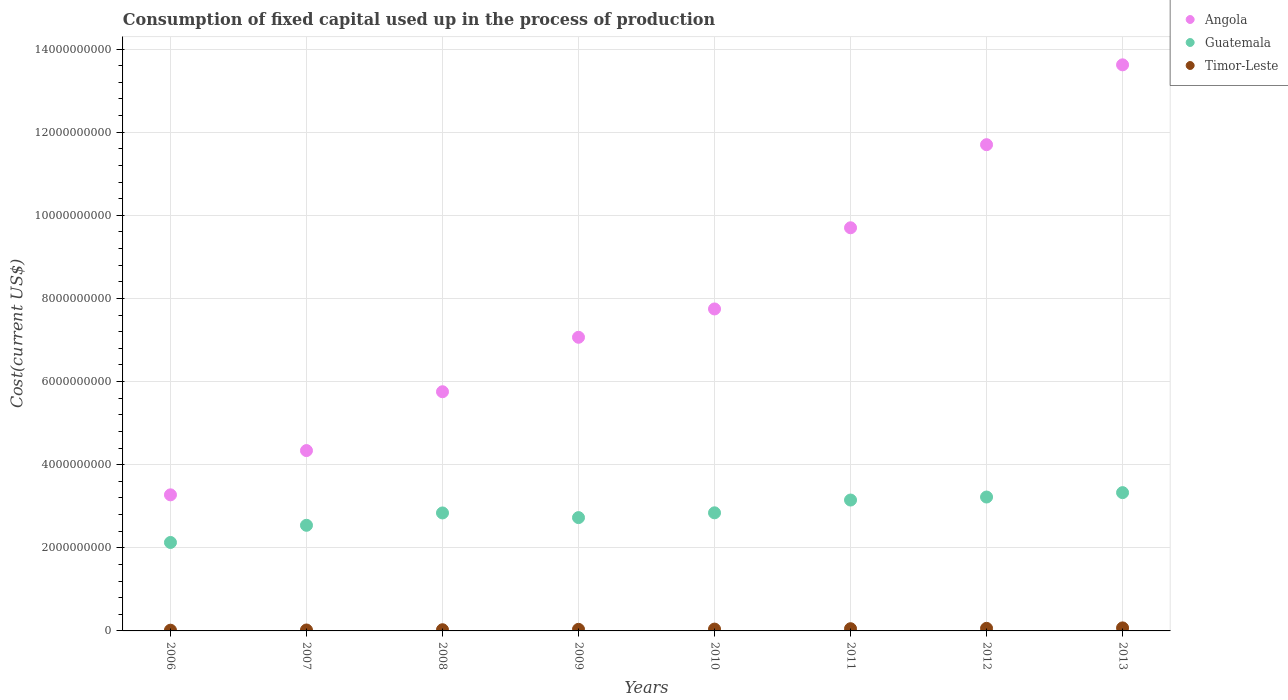How many different coloured dotlines are there?
Provide a short and direct response. 3. What is the amount consumed in the process of production in Guatemala in 2010?
Your response must be concise. 2.84e+09. Across all years, what is the maximum amount consumed in the process of production in Angola?
Give a very brief answer. 1.36e+1. Across all years, what is the minimum amount consumed in the process of production in Timor-Leste?
Ensure brevity in your answer.  1.75e+07. In which year was the amount consumed in the process of production in Timor-Leste maximum?
Your answer should be very brief. 2013. What is the total amount consumed in the process of production in Guatemala in the graph?
Ensure brevity in your answer.  2.28e+1. What is the difference between the amount consumed in the process of production in Angola in 2007 and that in 2010?
Provide a short and direct response. -3.41e+09. What is the difference between the amount consumed in the process of production in Timor-Leste in 2006 and the amount consumed in the process of production in Guatemala in 2012?
Your answer should be very brief. -3.20e+09. What is the average amount consumed in the process of production in Guatemala per year?
Offer a very short reply. 2.85e+09. In the year 2010, what is the difference between the amount consumed in the process of production in Guatemala and amount consumed in the process of production in Angola?
Offer a terse response. -4.91e+09. What is the ratio of the amount consumed in the process of production in Guatemala in 2010 to that in 2011?
Provide a succinct answer. 0.9. What is the difference between the highest and the second highest amount consumed in the process of production in Timor-Leste?
Provide a succinct answer. 1.07e+07. What is the difference between the highest and the lowest amount consumed in the process of production in Angola?
Give a very brief answer. 1.03e+1. In how many years, is the amount consumed in the process of production in Angola greater than the average amount consumed in the process of production in Angola taken over all years?
Make the answer very short. 3. Is it the case that in every year, the sum of the amount consumed in the process of production in Timor-Leste and amount consumed in the process of production in Guatemala  is greater than the amount consumed in the process of production in Angola?
Give a very brief answer. No. Is the amount consumed in the process of production in Timor-Leste strictly greater than the amount consumed in the process of production in Angola over the years?
Your answer should be very brief. No. How many dotlines are there?
Provide a succinct answer. 3. Are the values on the major ticks of Y-axis written in scientific E-notation?
Give a very brief answer. No. Does the graph contain any zero values?
Give a very brief answer. No. Does the graph contain grids?
Ensure brevity in your answer.  Yes. How many legend labels are there?
Your response must be concise. 3. How are the legend labels stacked?
Ensure brevity in your answer.  Vertical. What is the title of the graph?
Provide a succinct answer. Consumption of fixed capital used up in the process of production. Does "Czech Republic" appear as one of the legend labels in the graph?
Ensure brevity in your answer.  No. What is the label or title of the X-axis?
Your answer should be very brief. Years. What is the label or title of the Y-axis?
Make the answer very short. Cost(current US$). What is the Cost(current US$) in Angola in 2006?
Offer a very short reply. 3.27e+09. What is the Cost(current US$) in Guatemala in 2006?
Ensure brevity in your answer.  2.13e+09. What is the Cost(current US$) of Timor-Leste in 2006?
Make the answer very short. 1.75e+07. What is the Cost(current US$) of Angola in 2007?
Give a very brief answer. 4.34e+09. What is the Cost(current US$) of Guatemala in 2007?
Your response must be concise. 2.54e+09. What is the Cost(current US$) in Timor-Leste in 2007?
Provide a succinct answer. 2.24e+07. What is the Cost(current US$) of Angola in 2008?
Offer a terse response. 5.75e+09. What is the Cost(current US$) in Guatemala in 2008?
Ensure brevity in your answer.  2.84e+09. What is the Cost(current US$) in Timor-Leste in 2008?
Provide a short and direct response. 2.86e+07. What is the Cost(current US$) in Angola in 2009?
Keep it short and to the point. 7.07e+09. What is the Cost(current US$) in Guatemala in 2009?
Your response must be concise. 2.73e+09. What is the Cost(current US$) in Timor-Leste in 2009?
Offer a terse response. 3.83e+07. What is the Cost(current US$) of Angola in 2010?
Ensure brevity in your answer.  7.75e+09. What is the Cost(current US$) of Guatemala in 2010?
Your answer should be very brief. 2.84e+09. What is the Cost(current US$) of Timor-Leste in 2010?
Offer a very short reply. 4.41e+07. What is the Cost(current US$) in Angola in 2011?
Your answer should be compact. 9.70e+09. What is the Cost(current US$) of Guatemala in 2011?
Keep it short and to the point. 3.15e+09. What is the Cost(current US$) of Timor-Leste in 2011?
Offer a terse response. 5.32e+07. What is the Cost(current US$) in Angola in 2012?
Provide a short and direct response. 1.17e+1. What is the Cost(current US$) in Guatemala in 2012?
Provide a succinct answer. 3.22e+09. What is the Cost(current US$) of Timor-Leste in 2012?
Offer a very short reply. 6.21e+07. What is the Cost(current US$) in Angola in 2013?
Ensure brevity in your answer.  1.36e+1. What is the Cost(current US$) in Guatemala in 2013?
Keep it short and to the point. 3.33e+09. What is the Cost(current US$) in Timor-Leste in 2013?
Your answer should be compact. 7.29e+07. Across all years, what is the maximum Cost(current US$) of Angola?
Make the answer very short. 1.36e+1. Across all years, what is the maximum Cost(current US$) of Guatemala?
Provide a short and direct response. 3.33e+09. Across all years, what is the maximum Cost(current US$) in Timor-Leste?
Offer a terse response. 7.29e+07. Across all years, what is the minimum Cost(current US$) of Angola?
Offer a very short reply. 3.27e+09. Across all years, what is the minimum Cost(current US$) in Guatemala?
Your response must be concise. 2.13e+09. Across all years, what is the minimum Cost(current US$) of Timor-Leste?
Your response must be concise. 1.75e+07. What is the total Cost(current US$) of Angola in the graph?
Provide a short and direct response. 6.32e+1. What is the total Cost(current US$) of Guatemala in the graph?
Provide a succinct answer. 2.28e+1. What is the total Cost(current US$) of Timor-Leste in the graph?
Your answer should be compact. 3.39e+08. What is the difference between the Cost(current US$) of Angola in 2006 and that in 2007?
Your answer should be very brief. -1.07e+09. What is the difference between the Cost(current US$) in Guatemala in 2006 and that in 2007?
Your answer should be compact. -4.13e+08. What is the difference between the Cost(current US$) of Timor-Leste in 2006 and that in 2007?
Keep it short and to the point. -4.92e+06. What is the difference between the Cost(current US$) of Angola in 2006 and that in 2008?
Your answer should be very brief. -2.48e+09. What is the difference between the Cost(current US$) of Guatemala in 2006 and that in 2008?
Your answer should be compact. -7.11e+08. What is the difference between the Cost(current US$) of Timor-Leste in 2006 and that in 2008?
Give a very brief answer. -1.11e+07. What is the difference between the Cost(current US$) of Angola in 2006 and that in 2009?
Your answer should be compact. -3.79e+09. What is the difference between the Cost(current US$) in Guatemala in 2006 and that in 2009?
Your answer should be compact. -5.98e+08. What is the difference between the Cost(current US$) of Timor-Leste in 2006 and that in 2009?
Provide a succinct answer. -2.08e+07. What is the difference between the Cost(current US$) in Angola in 2006 and that in 2010?
Provide a succinct answer. -4.47e+09. What is the difference between the Cost(current US$) of Guatemala in 2006 and that in 2010?
Give a very brief answer. -7.13e+08. What is the difference between the Cost(current US$) in Timor-Leste in 2006 and that in 2010?
Your answer should be compact. -2.67e+07. What is the difference between the Cost(current US$) in Angola in 2006 and that in 2011?
Your response must be concise. -6.43e+09. What is the difference between the Cost(current US$) of Guatemala in 2006 and that in 2011?
Your answer should be compact. -1.02e+09. What is the difference between the Cost(current US$) in Timor-Leste in 2006 and that in 2011?
Ensure brevity in your answer.  -3.57e+07. What is the difference between the Cost(current US$) in Angola in 2006 and that in 2012?
Provide a succinct answer. -8.42e+09. What is the difference between the Cost(current US$) of Guatemala in 2006 and that in 2012?
Provide a short and direct response. -1.09e+09. What is the difference between the Cost(current US$) in Timor-Leste in 2006 and that in 2012?
Your answer should be very brief. -4.46e+07. What is the difference between the Cost(current US$) in Angola in 2006 and that in 2013?
Your answer should be compact. -1.03e+1. What is the difference between the Cost(current US$) of Guatemala in 2006 and that in 2013?
Offer a very short reply. -1.20e+09. What is the difference between the Cost(current US$) in Timor-Leste in 2006 and that in 2013?
Make the answer very short. -5.54e+07. What is the difference between the Cost(current US$) in Angola in 2007 and that in 2008?
Offer a very short reply. -1.42e+09. What is the difference between the Cost(current US$) in Guatemala in 2007 and that in 2008?
Your answer should be compact. -2.97e+08. What is the difference between the Cost(current US$) of Timor-Leste in 2007 and that in 2008?
Provide a short and direct response. -6.15e+06. What is the difference between the Cost(current US$) of Angola in 2007 and that in 2009?
Offer a terse response. -2.73e+09. What is the difference between the Cost(current US$) of Guatemala in 2007 and that in 2009?
Keep it short and to the point. -1.85e+08. What is the difference between the Cost(current US$) in Timor-Leste in 2007 and that in 2009?
Provide a short and direct response. -1.58e+07. What is the difference between the Cost(current US$) in Angola in 2007 and that in 2010?
Provide a succinct answer. -3.41e+09. What is the difference between the Cost(current US$) of Guatemala in 2007 and that in 2010?
Your answer should be compact. -3.00e+08. What is the difference between the Cost(current US$) in Timor-Leste in 2007 and that in 2010?
Provide a short and direct response. -2.17e+07. What is the difference between the Cost(current US$) in Angola in 2007 and that in 2011?
Offer a very short reply. -5.36e+09. What is the difference between the Cost(current US$) in Guatemala in 2007 and that in 2011?
Offer a very short reply. -6.08e+08. What is the difference between the Cost(current US$) in Timor-Leste in 2007 and that in 2011?
Keep it short and to the point. -3.08e+07. What is the difference between the Cost(current US$) of Angola in 2007 and that in 2012?
Provide a short and direct response. -7.36e+09. What is the difference between the Cost(current US$) in Guatemala in 2007 and that in 2012?
Provide a short and direct response. -6.80e+08. What is the difference between the Cost(current US$) of Timor-Leste in 2007 and that in 2012?
Your response must be concise. -3.97e+07. What is the difference between the Cost(current US$) in Angola in 2007 and that in 2013?
Your response must be concise. -9.28e+09. What is the difference between the Cost(current US$) in Guatemala in 2007 and that in 2013?
Your response must be concise. -7.86e+08. What is the difference between the Cost(current US$) in Timor-Leste in 2007 and that in 2013?
Offer a very short reply. -5.04e+07. What is the difference between the Cost(current US$) of Angola in 2008 and that in 2009?
Provide a short and direct response. -1.31e+09. What is the difference between the Cost(current US$) of Guatemala in 2008 and that in 2009?
Keep it short and to the point. 1.12e+08. What is the difference between the Cost(current US$) in Timor-Leste in 2008 and that in 2009?
Give a very brief answer. -9.69e+06. What is the difference between the Cost(current US$) in Angola in 2008 and that in 2010?
Your answer should be compact. -1.99e+09. What is the difference between the Cost(current US$) in Guatemala in 2008 and that in 2010?
Provide a short and direct response. -2.84e+06. What is the difference between the Cost(current US$) of Timor-Leste in 2008 and that in 2010?
Keep it short and to the point. -1.56e+07. What is the difference between the Cost(current US$) in Angola in 2008 and that in 2011?
Your answer should be very brief. -3.94e+09. What is the difference between the Cost(current US$) in Guatemala in 2008 and that in 2011?
Your answer should be very brief. -3.11e+08. What is the difference between the Cost(current US$) in Timor-Leste in 2008 and that in 2011?
Offer a terse response. -2.46e+07. What is the difference between the Cost(current US$) of Angola in 2008 and that in 2012?
Keep it short and to the point. -5.94e+09. What is the difference between the Cost(current US$) of Guatemala in 2008 and that in 2012?
Provide a short and direct response. -3.83e+08. What is the difference between the Cost(current US$) of Timor-Leste in 2008 and that in 2012?
Give a very brief answer. -3.36e+07. What is the difference between the Cost(current US$) in Angola in 2008 and that in 2013?
Offer a very short reply. -7.87e+09. What is the difference between the Cost(current US$) in Guatemala in 2008 and that in 2013?
Offer a terse response. -4.88e+08. What is the difference between the Cost(current US$) in Timor-Leste in 2008 and that in 2013?
Offer a terse response. -4.43e+07. What is the difference between the Cost(current US$) in Angola in 2009 and that in 2010?
Offer a very short reply. -6.82e+08. What is the difference between the Cost(current US$) of Guatemala in 2009 and that in 2010?
Your response must be concise. -1.15e+08. What is the difference between the Cost(current US$) in Timor-Leste in 2009 and that in 2010?
Provide a short and direct response. -5.89e+06. What is the difference between the Cost(current US$) in Angola in 2009 and that in 2011?
Ensure brevity in your answer.  -2.63e+09. What is the difference between the Cost(current US$) in Guatemala in 2009 and that in 2011?
Your response must be concise. -4.23e+08. What is the difference between the Cost(current US$) in Timor-Leste in 2009 and that in 2011?
Offer a terse response. -1.49e+07. What is the difference between the Cost(current US$) of Angola in 2009 and that in 2012?
Provide a short and direct response. -4.63e+09. What is the difference between the Cost(current US$) in Guatemala in 2009 and that in 2012?
Make the answer very short. -4.95e+08. What is the difference between the Cost(current US$) of Timor-Leste in 2009 and that in 2012?
Your response must be concise. -2.39e+07. What is the difference between the Cost(current US$) of Angola in 2009 and that in 2013?
Provide a succinct answer. -6.55e+09. What is the difference between the Cost(current US$) of Guatemala in 2009 and that in 2013?
Offer a terse response. -6.01e+08. What is the difference between the Cost(current US$) of Timor-Leste in 2009 and that in 2013?
Keep it short and to the point. -3.46e+07. What is the difference between the Cost(current US$) in Angola in 2010 and that in 2011?
Ensure brevity in your answer.  -1.95e+09. What is the difference between the Cost(current US$) of Guatemala in 2010 and that in 2011?
Keep it short and to the point. -3.08e+08. What is the difference between the Cost(current US$) in Timor-Leste in 2010 and that in 2011?
Offer a very short reply. -9.04e+06. What is the difference between the Cost(current US$) in Angola in 2010 and that in 2012?
Give a very brief answer. -3.95e+09. What is the difference between the Cost(current US$) in Guatemala in 2010 and that in 2012?
Keep it short and to the point. -3.80e+08. What is the difference between the Cost(current US$) of Timor-Leste in 2010 and that in 2012?
Give a very brief answer. -1.80e+07. What is the difference between the Cost(current US$) in Angola in 2010 and that in 2013?
Offer a terse response. -5.87e+09. What is the difference between the Cost(current US$) in Guatemala in 2010 and that in 2013?
Your answer should be very brief. -4.86e+08. What is the difference between the Cost(current US$) in Timor-Leste in 2010 and that in 2013?
Keep it short and to the point. -2.87e+07. What is the difference between the Cost(current US$) in Angola in 2011 and that in 2012?
Your response must be concise. -2.00e+09. What is the difference between the Cost(current US$) of Guatemala in 2011 and that in 2012?
Your response must be concise. -7.23e+07. What is the difference between the Cost(current US$) of Timor-Leste in 2011 and that in 2012?
Offer a very short reply. -8.93e+06. What is the difference between the Cost(current US$) in Angola in 2011 and that in 2013?
Your answer should be compact. -3.92e+09. What is the difference between the Cost(current US$) of Guatemala in 2011 and that in 2013?
Your response must be concise. -1.78e+08. What is the difference between the Cost(current US$) of Timor-Leste in 2011 and that in 2013?
Ensure brevity in your answer.  -1.97e+07. What is the difference between the Cost(current US$) in Angola in 2012 and that in 2013?
Provide a succinct answer. -1.92e+09. What is the difference between the Cost(current US$) of Guatemala in 2012 and that in 2013?
Provide a succinct answer. -1.06e+08. What is the difference between the Cost(current US$) in Timor-Leste in 2012 and that in 2013?
Your response must be concise. -1.07e+07. What is the difference between the Cost(current US$) of Angola in 2006 and the Cost(current US$) of Guatemala in 2007?
Your answer should be compact. 7.33e+08. What is the difference between the Cost(current US$) of Angola in 2006 and the Cost(current US$) of Timor-Leste in 2007?
Your response must be concise. 3.25e+09. What is the difference between the Cost(current US$) in Guatemala in 2006 and the Cost(current US$) in Timor-Leste in 2007?
Provide a succinct answer. 2.11e+09. What is the difference between the Cost(current US$) in Angola in 2006 and the Cost(current US$) in Guatemala in 2008?
Ensure brevity in your answer.  4.35e+08. What is the difference between the Cost(current US$) in Angola in 2006 and the Cost(current US$) in Timor-Leste in 2008?
Provide a succinct answer. 3.25e+09. What is the difference between the Cost(current US$) of Guatemala in 2006 and the Cost(current US$) of Timor-Leste in 2008?
Your answer should be compact. 2.10e+09. What is the difference between the Cost(current US$) of Angola in 2006 and the Cost(current US$) of Guatemala in 2009?
Ensure brevity in your answer.  5.48e+08. What is the difference between the Cost(current US$) in Angola in 2006 and the Cost(current US$) in Timor-Leste in 2009?
Provide a succinct answer. 3.24e+09. What is the difference between the Cost(current US$) in Guatemala in 2006 and the Cost(current US$) in Timor-Leste in 2009?
Offer a very short reply. 2.09e+09. What is the difference between the Cost(current US$) in Angola in 2006 and the Cost(current US$) in Guatemala in 2010?
Give a very brief answer. 4.33e+08. What is the difference between the Cost(current US$) of Angola in 2006 and the Cost(current US$) of Timor-Leste in 2010?
Your answer should be compact. 3.23e+09. What is the difference between the Cost(current US$) in Guatemala in 2006 and the Cost(current US$) in Timor-Leste in 2010?
Your answer should be very brief. 2.08e+09. What is the difference between the Cost(current US$) in Angola in 2006 and the Cost(current US$) in Guatemala in 2011?
Provide a short and direct response. 1.25e+08. What is the difference between the Cost(current US$) of Angola in 2006 and the Cost(current US$) of Timor-Leste in 2011?
Provide a short and direct response. 3.22e+09. What is the difference between the Cost(current US$) of Guatemala in 2006 and the Cost(current US$) of Timor-Leste in 2011?
Provide a succinct answer. 2.07e+09. What is the difference between the Cost(current US$) of Angola in 2006 and the Cost(current US$) of Guatemala in 2012?
Offer a very short reply. 5.26e+07. What is the difference between the Cost(current US$) of Angola in 2006 and the Cost(current US$) of Timor-Leste in 2012?
Your answer should be compact. 3.21e+09. What is the difference between the Cost(current US$) in Guatemala in 2006 and the Cost(current US$) in Timor-Leste in 2012?
Give a very brief answer. 2.07e+09. What is the difference between the Cost(current US$) in Angola in 2006 and the Cost(current US$) in Guatemala in 2013?
Ensure brevity in your answer.  -5.30e+07. What is the difference between the Cost(current US$) of Angola in 2006 and the Cost(current US$) of Timor-Leste in 2013?
Keep it short and to the point. 3.20e+09. What is the difference between the Cost(current US$) of Guatemala in 2006 and the Cost(current US$) of Timor-Leste in 2013?
Your answer should be compact. 2.06e+09. What is the difference between the Cost(current US$) in Angola in 2007 and the Cost(current US$) in Guatemala in 2008?
Your response must be concise. 1.50e+09. What is the difference between the Cost(current US$) in Angola in 2007 and the Cost(current US$) in Timor-Leste in 2008?
Keep it short and to the point. 4.31e+09. What is the difference between the Cost(current US$) in Guatemala in 2007 and the Cost(current US$) in Timor-Leste in 2008?
Your response must be concise. 2.51e+09. What is the difference between the Cost(current US$) of Angola in 2007 and the Cost(current US$) of Guatemala in 2009?
Provide a succinct answer. 1.61e+09. What is the difference between the Cost(current US$) in Angola in 2007 and the Cost(current US$) in Timor-Leste in 2009?
Make the answer very short. 4.30e+09. What is the difference between the Cost(current US$) of Guatemala in 2007 and the Cost(current US$) of Timor-Leste in 2009?
Make the answer very short. 2.50e+09. What is the difference between the Cost(current US$) of Angola in 2007 and the Cost(current US$) of Guatemala in 2010?
Your answer should be very brief. 1.50e+09. What is the difference between the Cost(current US$) of Angola in 2007 and the Cost(current US$) of Timor-Leste in 2010?
Offer a very short reply. 4.30e+09. What is the difference between the Cost(current US$) in Guatemala in 2007 and the Cost(current US$) in Timor-Leste in 2010?
Your answer should be compact. 2.50e+09. What is the difference between the Cost(current US$) in Angola in 2007 and the Cost(current US$) in Guatemala in 2011?
Your response must be concise. 1.19e+09. What is the difference between the Cost(current US$) in Angola in 2007 and the Cost(current US$) in Timor-Leste in 2011?
Make the answer very short. 4.29e+09. What is the difference between the Cost(current US$) of Guatemala in 2007 and the Cost(current US$) of Timor-Leste in 2011?
Provide a succinct answer. 2.49e+09. What is the difference between the Cost(current US$) of Angola in 2007 and the Cost(current US$) of Guatemala in 2012?
Offer a very short reply. 1.12e+09. What is the difference between the Cost(current US$) in Angola in 2007 and the Cost(current US$) in Timor-Leste in 2012?
Your response must be concise. 4.28e+09. What is the difference between the Cost(current US$) in Guatemala in 2007 and the Cost(current US$) in Timor-Leste in 2012?
Your answer should be very brief. 2.48e+09. What is the difference between the Cost(current US$) in Angola in 2007 and the Cost(current US$) in Guatemala in 2013?
Provide a short and direct response. 1.01e+09. What is the difference between the Cost(current US$) of Angola in 2007 and the Cost(current US$) of Timor-Leste in 2013?
Offer a very short reply. 4.27e+09. What is the difference between the Cost(current US$) in Guatemala in 2007 and the Cost(current US$) in Timor-Leste in 2013?
Your response must be concise. 2.47e+09. What is the difference between the Cost(current US$) in Angola in 2008 and the Cost(current US$) in Guatemala in 2009?
Keep it short and to the point. 3.03e+09. What is the difference between the Cost(current US$) in Angola in 2008 and the Cost(current US$) in Timor-Leste in 2009?
Your answer should be compact. 5.72e+09. What is the difference between the Cost(current US$) in Guatemala in 2008 and the Cost(current US$) in Timor-Leste in 2009?
Offer a terse response. 2.80e+09. What is the difference between the Cost(current US$) of Angola in 2008 and the Cost(current US$) of Guatemala in 2010?
Offer a very short reply. 2.91e+09. What is the difference between the Cost(current US$) of Angola in 2008 and the Cost(current US$) of Timor-Leste in 2010?
Your answer should be very brief. 5.71e+09. What is the difference between the Cost(current US$) of Guatemala in 2008 and the Cost(current US$) of Timor-Leste in 2010?
Ensure brevity in your answer.  2.79e+09. What is the difference between the Cost(current US$) of Angola in 2008 and the Cost(current US$) of Guatemala in 2011?
Make the answer very short. 2.61e+09. What is the difference between the Cost(current US$) of Angola in 2008 and the Cost(current US$) of Timor-Leste in 2011?
Offer a terse response. 5.70e+09. What is the difference between the Cost(current US$) in Guatemala in 2008 and the Cost(current US$) in Timor-Leste in 2011?
Your answer should be very brief. 2.79e+09. What is the difference between the Cost(current US$) of Angola in 2008 and the Cost(current US$) of Guatemala in 2012?
Ensure brevity in your answer.  2.53e+09. What is the difference between the Cost(current US$) of Angola in 2008 and the Cost(current US$) of Timor-Leste in 2012?
Give a very brief answer. 5.69e+09. What is the difference between the Cost(current US$) of Guatemala in 2008 and the Cost(current US$) of Timor-Leste in 2012?
Your answer should be compact. 2.78e+09. What is the difference between the Cost(current US$) in Angola in 2008 and the Cost(current US$) in Guatemala in 2013?
Your response must be concise. 2.43e+09. What is the difference between the Cost(current US$) in Angola in 2008 and the Cost(current US$) in Timor-Leste in 2013?
Offer a terse response. 5.68e+09. What is the difference between the Cost(current US$) of Guatemala in 2008 and the Cost(current US$) of Timor-Leste in 2013?
Provide a succinct answer. 2.77e+09. What is the difference between the Cost(current US$) in Angola in 2009 and the Cost(current US$) in Guatemala in 2010?
Give a very brief answer. 4.22e+09. What is the difference between the Cost(current US$) in Angola in 2009 and the Cost(current US$) in Timor-Leste in 2010?
Your answer should be compact. 7.02e+09. What is the difference between the Cost(current US$) in Guatemala in 2009 and the Cost(current US$) in Timor-Leste in 2010?
Your answer should be compact. 2.68e+09. What is the difference between the Cost(current US$) of Angola in 2009 and the Cost(current US$) of Guatemala in 2011?
Provide a succinct answer. 3.92e+09. What is the difference between the Cost(current US$) in Angola in 2009 and the Cost(current US$) in Timor-Leste in 2011?
Provide a succinct answer. 7.01e+09. What is the difference between the Cost(current US$) of Guatemala in 2009 and the Cost(current US$) of Timor-Leste in 2011?
Keep it short and to the point. 2.67e+09. What is the difference between the Cost(current US$) in Angola in 2009 and the Cost(current US$) in Guatemala in 2012?
Your response must be concise. 3.84e+09. What is the difference between the Cost(current US$) of Angola in 2009 and the Cost(current US$) of Timor-Leste in 2012?
Your answer should be very brief. 7.00e+09. What is the difference between the Cost(current US$) in Guatemala in 2009 and the Cost(current US$) in Timor-Leste in 2012?
Your response must be concise. 2.66e+09. What is the difference between the Cost(current US$) of Angola in 2009 and the Cost(current US$) of Guatemala in 2013?
Your answer should be very brief. 3.74e+09. What is the difference between the Cost(current US$) of Angola in 2009 and the Cost(current US$) of Timor-Leste in 2013?
Your answer should be very brief. 6.99e+09. What is the difference between the Cost(current US$) of Guatemala in 2009 and the Cost(current US$) of Timor-Leste in 2013?
Ensure brevity in your answer.  2.65e+09. What is the difference between the Cost(current US$) in Angola in 2010 and the Cost(current US$) in Guatemala in 2011?
Offer a terse response. 4.60e+09. What is the difference between the Cost(current US$) in Angola in 2010 and the Cost(current US$) in Timor-Leste in 2011?
Provide a succinct answer. 7.69e+09. What is the difference between the Cost(current US$) in Guatemala in 2010 and the Cost(current US$) in Timor-Leste in 2011?
Ensure brevity in your answer.  2.79e+09. What is the difference between the Cost(current US$) in Angola in 2010 and the Cost(current US$) in Guatemala in 2012?
Your answer should be compact. 4.53e+09. What is the difference between the Cost(current US$) of Angola in 2010 and the Cost(current US$) of Timor-Leste in 2012?
Provide a succinct answer. 7.68e+09. What is the difference between the Cost(current US$) of Guatemala in 2010 and the Cost(current US$) of Timor-Leste in 2012?
Make the answer very short. 2.78e+09. What is the difference between the Cost(current US$) of Angola in 2010 and the Cost(current US$) of Guatemala in 2013?
Your response must be concise. 4.42e+09. What is the difference between the Cost(current US$) of Angola in 2010 and the Cost(current US$) of Timor-Leste in 2013?
Make the answer very short. 7.67e+09. What is the difference between the Cost(current US$) in Guatemala in 2010 and the Cost(current US$) in Timor-Leste in 2013?
Your response must be concise. 2.77e+09. What is the difference between the Cost(current US$) in Angola in 2011 and the Cost(current US$) in Guatemala in 2012?
Your answer should be compact. 6.48e+09. What is the difference between the Cost(current US$) of Angola in 2011 and the Cost(current US$) of Timor-Leste in 2012?
Your response must be concise. 9.64e+09. What is the difference between the Cost(current US$) of Guatemala in 2011 and the Cost(current US$) of Timor-Leste in 2012?
Provide a succinct answer. 3.09e+09. What is the difference between the Cost(current US$) in Angola in 2011 and the Cost(current US$) in Guatemala in 2013?
Your response must be concise. 6.37e+09. What is the difference between the Cost(current US$) of Angola in 2011 and the Cost(current US$) of Timor-Leste in 2013?
Your answer should be very brief. 9.63e+09. What is the difference between the Cost(current US$) in Guatemala in 2011 and the Cost(current US$) in Timor-Leste in 2013?
Offer a very short reply. 3.08e+09. What is the difference between the Cost(current US$) in Angola in 2012 and the Cost(current US$) in Guatemala in 2013?
Keep it short and to the point. 8.37e+09. What is the difference between the Cost(current US$) of Angola in 2012 and the Cost(current US$) of Timor-Leste in 2013?
Give a very brief answer. 1.16e+1. What is the difference between the Cost(current US$) of Guatemala in 2012 and the Cost(current US$) of Timor-Leste in 2013?
Keep it short and to the point. 3.15e+09. What is the average Cost(current US$) of Angola per year?
Make the answer very short. 7.90e+09. What is the average Cost(current US$) in Guatemala per year?
Your response must be concise. 2.85e+09. What is the average Cost(current US$) in Timor-Leste per year?
Your answer should be compact. 4.24e+07. In the year 2006, what is the difference between the Cost(current US$) in Angola and Cost(current US$) in Guatemala?
Provide a succinct answer. 1.15e+09. In the year 2006, what is the difference between the Cost(current US$) in Angola and Cost(current US$) in Timor-Leste?
Offer a terse response. 3.26e+09. In the year 2006, what is the difference between the Cost(current US$) of Guatemala and Cost(current US$) of Timor-Leste?
Give a very brief answer. 2.11e+09. In the year 2007, what is the difference between the Cost(current US$) of Angola and Cost(current US$) of Guatemala?
Offer a terse response. 1.80e+09. In the year 2007, what is the difference between the Cost(current US$) of Angola and Cost(current US$) of Timor-Leste?
Your answer should be very brief. 4.32e+09. In the year 2007, what is the difference between the Cost(current US$) of Guatemala and Cost(current US$) of Timor-Leste?
Ensure brevity in your answer.  2.52e+09. In the year 2008, what is the difference between the Cost(current US$) in Angola and Cost(current US$) in Guatemala?
Make the answer very short. 2.92e+09. In the year 2008, what is the difference between the Cost(current US$) of Angola and Cost(current US$) of Timor-Leste?
Your response must be concise. 5.73e+09. In the year 2008, what is the difference between the Cost(current US$) in Guatemala and Cost(current US$) in Timor-Leste?
Your response must be concise. 2.81e+09. In the year 2009, what is the difference between the Cost(current US$) in Angola and Cost(current US$) in Guatemala?
Give a very brief answer. 4.34e+09. In the year 2009, what is the difference between the Cost(current US$) of Angola and Cost(current US$) of Timor-Leste?
Provide a short and direct response. 7.03e+09. In the year 2009, what is the difference between the Cost(current US$) of Guatemala and Cost(current US$) of Timor-Leste?
Provide a short and direct response. 2.69e+09. In the year 2010, what is the difference between the Cost(current US$) of Angola and Cost(current US$) of Guatemala?
Offer a very short reply. 4.91e+09. In the year 2010, what is the difference between the Cost(current US$) of Angola and Cost(current US$) of Timor-Leste?
Ensure brevity in your answer.  7.70e+09. In the year 2010, what is the difference between the Cost(current US$) of Guatemala and Cost(current US$) of Timor-Leste?
Offer a very short reply. 2.80e+09. In the year 2011, what is the difference between the Cost(current US$) of Angola and Cost(current US$) of Guatemala?
Your response must be concise. 6.55e+09. In the year 2011, what is the difference between the Cost(current US$) in Angola and Cost(current US$) in Timor-Leste?
Your answer should be very brief. 9.65e+09. In the year 2011, what is the difference between the Cost(current US$) in Guatemala and Cost(current US$) in Timor-Leste?
Your response must be concise. 3.10e+09. In the year 2012, what is the difference between the Cost(current US$) of Angola and Cost(current US$) of Guatemala?
Offer a very short reply. 8.48e+09. In the year 2012, what is the difference between the Cost(current US$) in Angola and Cost(current US$) in Timor-Leste?
Offer a terse response. 1.16e+1. In the year 2012, what is the difference between the Cost(current US$) in Guatemala and Cost(current US$) in Timor-Leste?
Give a very brief answer. 3.16e+09. In the year 2013, what is the difference between the Cost(current US$) in Angola and Cost(current US$) in Guatemala?
Your response must be concise. 1.03e+1. In the year 2013, what is the difference between the Cost(current US$) of Angola and Cost(current US$) of Timor-Leste?
Offer a very short reply. 1.35e+1. In the year 2013, what is the difference between the Cost(current US$) of Guatemala and Cost(current US$) of Timor-Leste?
Your response must be concise. 3.25e+09. What is the ratio of the Cost(current US$) in Angola in 2006 to that in 2007?
Provide a short and direct response. 0.75. What is the ratio of the Cost(current US$) of Guatemala in 2006 to that in 2007?
Keep it short and to the point. 0.84. What is the ratio of the Cost(current US$) in Timor-Leste in 2006 to that in 2007?
Keep it short and to the point. 0.78. What is the ratio of the Cost(current US$) of Angola in 2006 to that in 2008?
Offer a terse response. 0.57. What is the ratio of the Cost(current US$) of Guatemala in 2006 to that in 2008?
Your answer should be compact. 0.75. What is the ratio of the Cost(current US$) in Timor-Leste in 2006 to that in 2008?
Keep it short and to the point. 0.61. What is the ratio of the Cost(current US$) of Angola in 2006 to that in 2009?
Keep it short and to the point. 0.46. What is the ratio of the Cost(current US$) of Guatemala in 2006 to that in 2009?
Your response must be concise. 0.78. What is the ratio of the Cost(current US$) in Timor-Leste in 2006 to that in 2009?
Provide a succinct answer. 0.46. What is the ratio of the Cost(current US$) in Angola in 2006 to that in 2010?
Offer a very short reply. 0.42. What is the ratio of the Cost(current US$) in Guatemala in 2006 to that in 2010?
Keep it short and to the point. 0.75. What is the ratio of the Cost(current US$) of Timor-Leste in 2006 to that in 2010?
Ensure brevity in your answer.  0.4. What is the ratio of the Cost(current US$) of Angola in 2006 to that in 2011?
Offer a very short reply. 0.34. What is the ratio of the Cost(current US$) of Guatemala in 2006 to that in 2011?
Ensure brevity in your answer.  0.68. What is the ratio of the Cost(current US$) in Timor-Leste in 2006 to that in 2011?
Provide a succinct answer. 0.33. What is the ratio of the Cost(current US$) of Angola in 2006 to that in 2012?
Provide a succinct answer. 0.28. What is the ratio of the Cost(current US$) in Guatemala in 2006 to that in 2012?
Provide a short and direct response. 0.66. What is the ratio of the Cost(current US$) of Timor-Leste in 2006 to that in 2012?
Provide a short and direct response. 0.28. What is the ratio of the Cost(current US$) of Angola in 2006 to that in 2013?
Your answer should be compact. 0.24. What is the ratio of the Cost(current US$) in Guatemala in 2006 to that in 2013?
Your answer should be very brief. 0.64. What is the ratio of the Cost(current US$) in Timor-Leste in 2006 to that in 2013?
Ensure brevity in your answer.  0.24. What is the ratio of the Cost(current US$) of Angola in 2007 to that in 2008?
Make the answer very short. 0.75. What is the ratio of the Cost(current US$) in Guatemala in 2007 to that in 2008?
Offer a very short reply. 0.9. What is the ratio of the Cost(current US$) of Timor-Leste in 2007 to that in 2008?
Make the answer very short. 0.78. What is the ratio of the Cost(current US$) in Angola in 2007 to that in 2009?
Your answer should be very brief. 0.61. What is the ratio of the Cost(current US$) of Guatemala in 2007 to that in 2009?
Offer a terse response. 0.93. What is the ratio of the Cost(current US$) of Timor-Leste in 2007 to that in 2009?
Offer a terse response. 0.59. What is the ratio of the Cost(current US$) in Angola in 2007 to that in 2010?
Give a very brief answer. 0.56. What is the ratio of the Cost(current US$) of Guatemala in 2007 to that in 2010?
Provide a succinct answer. 0.89. What is the ratio of the Cost(current US$) of Timor-Leste in 2007 to that in 2010?
Offer a very short reply. 0.51. What is the ratio of the Cost(current US$) of Angola in 2007 to that in 2011?
Your answer should be very brief. 0.45. What is the ratio of the Cost(current US$) in Guatemala in 2007 to that in 2011?
Your response must be concise. 0.81. What is the ratio of the Cost(current US$) of Timor-Leste in 2007 to that in 2011?
Provide a short and direct response. 0.42. What is the ratio of the Cost(current US$) in Angola in 2007 to that in 2012?
Keep it short and to the point. 0.37. What is the ratio of the Cost(current US$) of Guatemala in 2007 to that in 2012?
Your response must be concise. 0.79. What is the ratio of the Cost(current US$) in Timor-Leste in 2007 to that in 2012?
Your response must be concise. 0.36. What is the ratio of the Cost(current US$) in Angola in 2007 to that in 2013?
Your response must be concise. 0.32. What is the ratio of the Cost(current US$) of Guatemala in 2007 to that in 2013?
Provide a succinct answer. 0.76. What is the ratio of the Cost(current US$) in Timor-Leste in 2007 to that in 2013?
Give a very brief answer. 0.31. What is the ratio of the Cost(current US$) of Angola in 2008 to that in 2009?
Make the answer very short. 0.81. What is the ratio of the Cost(current US$) of Guatemala in 2008 to that in 2009?
Your answer should be compact. 1.04. What is the ratio of the Cost(current US$) in Timor-Leste in 2008 to that in 2009?
Keep it short and to the point. 0.75. What is the ratio of the Cost(current US$) in Angola in 2008 to that in 2010?
Your answer should be very brief. 0.74. What is the ratio of the Cost(current US$) of Guatemala in 2008 to that in 2010?
Provide a succinct answer. 1. What is the ratio of the Cost(current US$) in Timor-Leste in 2008 to that in 2010?
Your answer should be compact. 0.65. What is the ratio of the Cost(current US$) of Angola in 2008 to that in 2011?
Your response must be concise. 0.59. What is the ratio of the Cost(current US$) of Guatemala in 2008 to that in 2011?
Make the answer very short. 0.9. What is the ratio of the Cost(current US$) of Timor-Leste in 2008 to that in 2011?
Provide a succinct answer. 0.54. What is the ratio of the Cost(current US$) of Angola in 2008 to that in 2012?
Provide a succinct answer. 0.49. What is the ratio of the Cost(current US$) of Guatemala in 2008 to that in 2012?
Keep it short and to the point. 0.88. What is the ratio of the Cost(current US$) of Timor-Leste in 2008 to that in 2012?
Ensure brevity in your answer.  0.46. What is the ratio of the Cost(current US$) of Angola in 2008 to that in 2013?
Make the answer very short. 0.42. What is the ratio of the Cost(current US$) of Guatemala in 2008 to that in 2013?
Ensure brevity in your answer.  0.85. What is the ratio of the Cost(current US$) of Timor-Leste in 2008 to that in 2013?
Offer a terse response. 0.39. What is the ratio of the Cost(current US$) in Angola in 2009 to that in 2010?
Provide a succinct answer. 0.91. What is the ratio of the Cost(current US$) of Guatemala in 2009 to that in 2010?
Your answer should be compact. 0.96. What is the ratio of the Cost(current US$) of Timor-Leste in 2009 to that in 2010?
Your response must be concise. 0.87. What is the ratio of the Cost(current US$) of Angola in 2009 to that in 2011?
Keep it short and to the point. 0.73. What is the ratio of the Cost(current US$) in Guatemala in 2009 to that in 2011?
Offer a terse response. 0.87. What is the ratio of the Cost(current US$) in Timor-Leste in 2009 to that in 2011?
Your response must be concise. 0.72. What is the ratio of the Cost(current US$) of Angola in 2009 to that in 2012?
Provide a short and direct response. 0.6. What is the ratio of the Cost(current US$) of Guatemala in 2009 to that in 2012?
Offer a very short reply. 0.85. What is the ratio of the Cost(current US$) in Timor-Leste in 2009 to that in 2012?
Your response must be concise. 0.62. What is the ratio of the Cost(current US$) of Angola in 2009 to that in 2013?
Offer a very short reply. 0.52. What is the ratio of the Cost(current US$) of Guatemala in 2009 to that in 2013?
Your response must be concise. 0.82. What is the ratio of the Cost(current US$) in Timor-Leste in 2009 to that in 2013?
Make the answer very short. 0.53. What is the ratio of the Cost(current US$) of Angola in 2010 to that in 2011?
Offer a terse response. 0.8. What is the ratio of the Cost(current US$) in Guatemala in 2010 to that in 2011?
Provide a short and direct response. 0.9. What is the ratio of the Cost(current US$) of Timor-Leste in 2010 to that in 2011?
Give a very brief answer. 0.83. What is the ratio of the Cost(current US$) of Angola in 2010 to that in 2012?
Your answer should be compact. 0.66. What is the ratio of the Cost(current US$) of Guatemala in 2010 to that in 2012?
Your response must be concise. 0.88. What is the ratio of the Cost(current US$) in Timor-Leste in 2010 to that in 2012?
Give a very brief answer. 0.71. What is the ratio of the Cost(current US$) in Angola in 2010 to that in 2013?
Offer a terse response. 0.57. What is the ratio of the Cost(current US$) in Guatemala in 2010 to that in 2013?
Your response must be concise. 0.85. What is the ratio of the Cost(current US$) of Timor-Leste in 2010 to that in 2013?
Ensure brevity in your answer.  0.61. What is the ratio of the Cost(current US$) of Angola in 2011 to that in 2012?
Give a very brief answer. 0.83. What is the ratio of the Cost(current US$) in Guatemala in 2011 to that in 2012?
Keep it short and to the point. 0.98. What is the ratio of the Cost(current US$) in Timor-Leste in 2011 to that in 2012?
Give a very brief answer. 0.86. What is the ratio of the Cost(current US$) in Angola in 2011 to that in 2013?
Your response must be concise. 0.71. What is the ratio of the Cost(current US$) of Guatemala in 2011 to that in 2013?
Provide a short and direct response. 0.95. What is the ratio of the Cost(current US$) of Timor-Leste in 2011 to that in 2013?
Ensure brevity in your answer.  0.73. What is the ratio of the Cost(current US$) in Angola in 2012 to that in 2013?
Your answer should be very brief. 0.86. What is the ratio of the Cost(current US$) of Guatemala in 2012 to that in 2013?
Offer a very short reply. 0.97. What is the ratio of the Cost(current US$) in Timor-Leste in 2012 to that in 2013?
Your answer should be very brief. 0.85. What is the difference between the highest and the second highest Cost(current US$) of Angola?
Offer a very short reply. 1.92e+09. What is the difference between the highest and the second highest Cost(current US$) in Guatemala?
Offer a very short reply. 1.06e+08. What is the difference between the highest and the second highest Cost(current US$) in Timor-Leste?
Your answer should be very brief. 1.07e+07. What is the difference between the highest and the lowest Cost(current US$) of Angola?
Keep it short and to the point. 1.03e+1. What is the difference between the highest and the lowest Cost(current US$) in Guatemala?
Offer a terse response. 1.20e+09. What is the difference between the highest and the lowest Cost(current US$) in Timor-Leste?
Your response must be concise. 5.54e+07. 